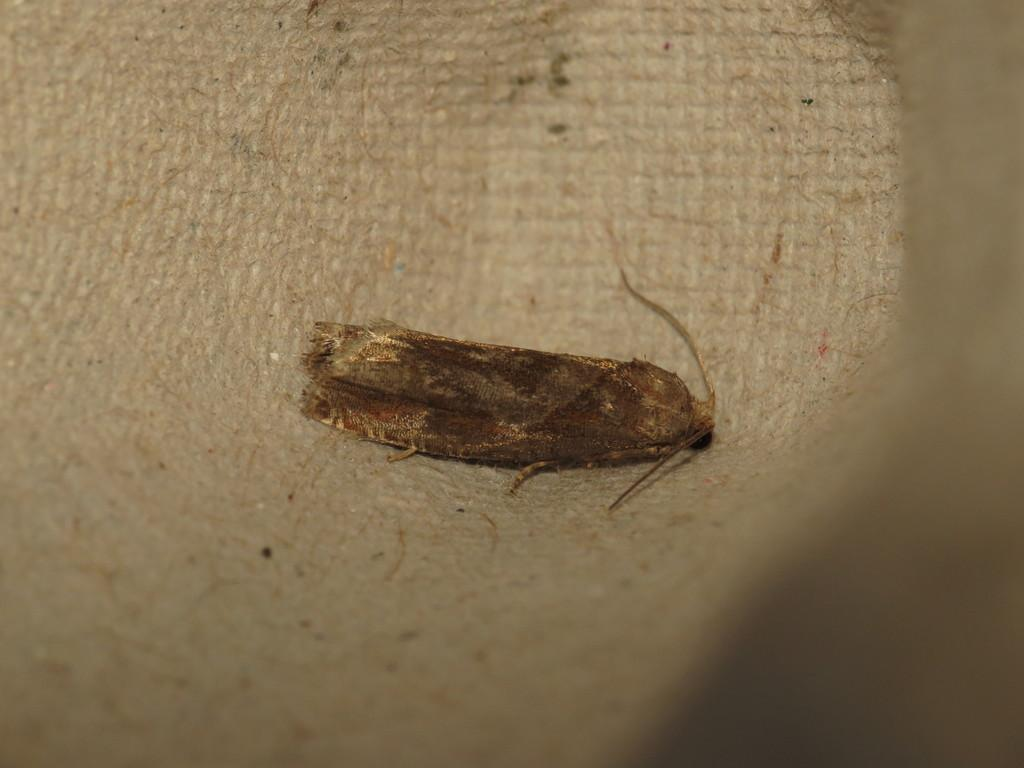What type of creature can be seen on the surface in the image? There is an insect on the surface in the image. What type of pie is being served in the cave scene depicted in the image? There is no pie or cave scene present in the image; it features an insect on a surface. 